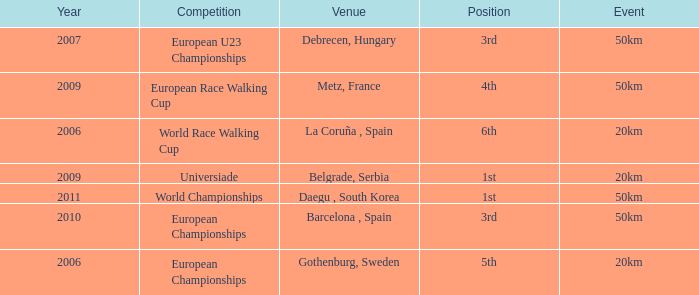What is the Position for the European U23 Championships? 3rd. 